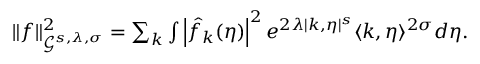<formula> <loc_0><loc_0><loc_500><loc_500>\begin{array} { r } { \| f \| _ { \mathcal { G } ^ { s , \lambda , \sigma } } ^ { 2 } = \sum _ { k } \int \left | \hat { f } _ { k } ( \eta ) \right | ^ { 2 } e ^ { 2 \lambda | k , \eta | ^ { s } } \langle k , \eta \rangle ^ { 2 \sigma } d \eta . } \end{array}</formula> 